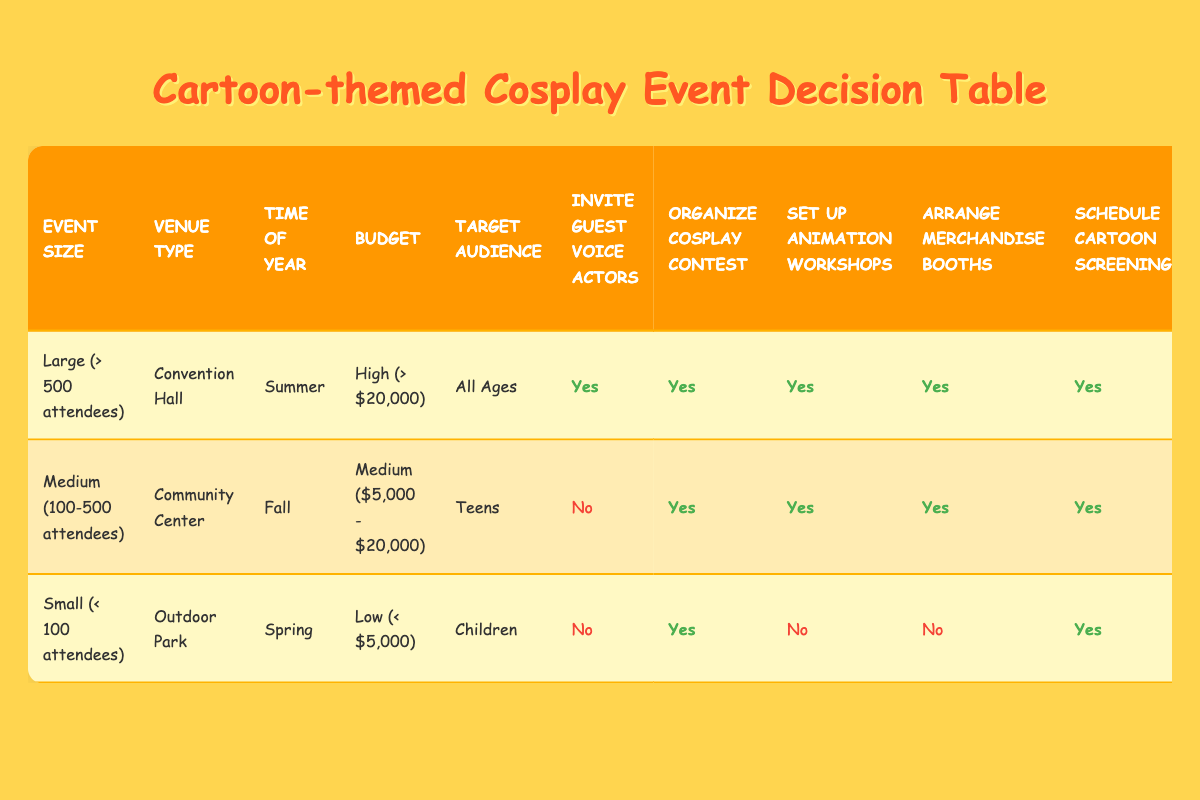What is the venue type for the large event? The row for the large event shows "Venue Type" has "Convention Hall." This is a direct retrieval question based on the table's first data row.
Answer: Convention Hall Do all actions get approved for large events? Looking at the row for the large event, every action ("Invite Guest Voice Actors," "Organize Cosplay Contest," "Set Up Animation Workshops," "Arrange Merchandise Booths," "Schedule Cartoon Screenings," and "Offer Food Themed After Popular Cartoons") is marked as "Yes." Therefore, all actions are approved for large events.
Answer: Yes What is the target audience for the medium-sized event? Referring to the medium-sized event row, the "Target Audience" is listed as "Teens." This can be answered directly from that row.
Answer: Teens Which event size has the least number of approvals for actions? The small event has actions marked as "No" for "Invite Guest Voice Actors," "Set Up Animation Workshops," and "Arrange Merchandise Booths." Comparing this with the others, it has the most "No" responses for the actions, indicating it has the least number of approvals.
Answer: Small (< 100 attendees) Does the medium-sized event offer food themed after popular cartoons? From the medium-sized event row, the action "Offer Food Themed After Popular Cartoons" is marked as "No." This is a fact-based question directly verifiable from the table.
Answer: No What is the budget range for the small-sized event, and does it organize animation workshops? The budget for the small-sized event is "Low (< $5,000)," and the action "Set Up Animation Workshops" is marked as "No." First, the budget is found from the relevant row, then the action status is confirmed, indicating that the small event does not organize workshops.
Answer: Low (< $5,000), No For medium events, how many total activities are planned that involve direct interaction with attendees? The medium-sized event plans "Organize Cosplay Contest," "Set Up Animation Workshops," and "Arrange Merchandise Booths," totaling three activities that involve direct interaction. To find this, count the "Yes" responses for these interactive actions in the medium-sized event row.
Answer: 3 When does the small event take place? The row for the small-sized event lists the "Time of Year" as "Spring." This is directly retrievable from that row in the table.
Answer: Spring 